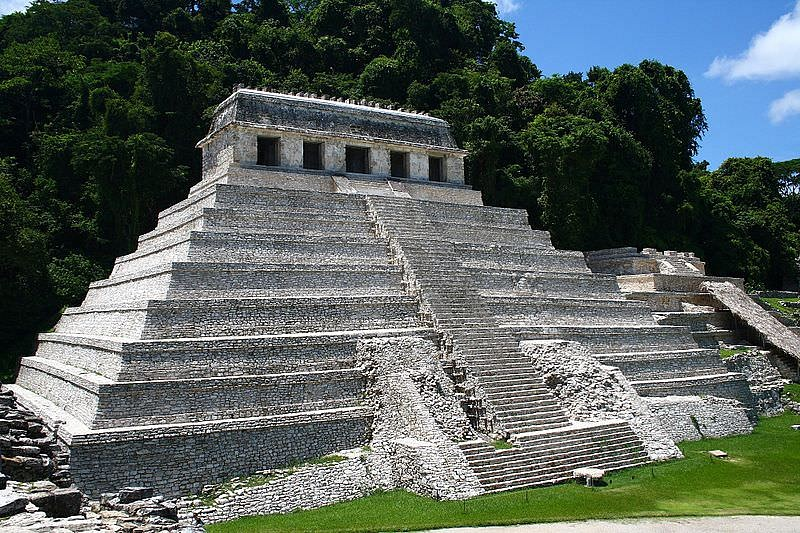What kind of activities might have taken place at the Temple of the Inscriptions? The Temple of the Inscriptions was likely a central hub for various significant activities in the ancient Mayan city of Palenque. Religious ceremonies and rituals would have been a primary function, given the temple's spiritual and cultural significance. The steps leading up to the temple might have been the scene of processions and other ceremonial activities. Additionally, the temple could have served as a tomb for the esteemed ruler Pacal the Great, as it is famously known to house his elaborate sarcophagus. Councils or meetings concerning state affairs might have also been conducted here, given the temple's prominence. The surrounding areas, rich with lush greenery, may have hosted communal gatherings, festivals, and social interactions, blending the sacred with the everyday life of the Mayans. 